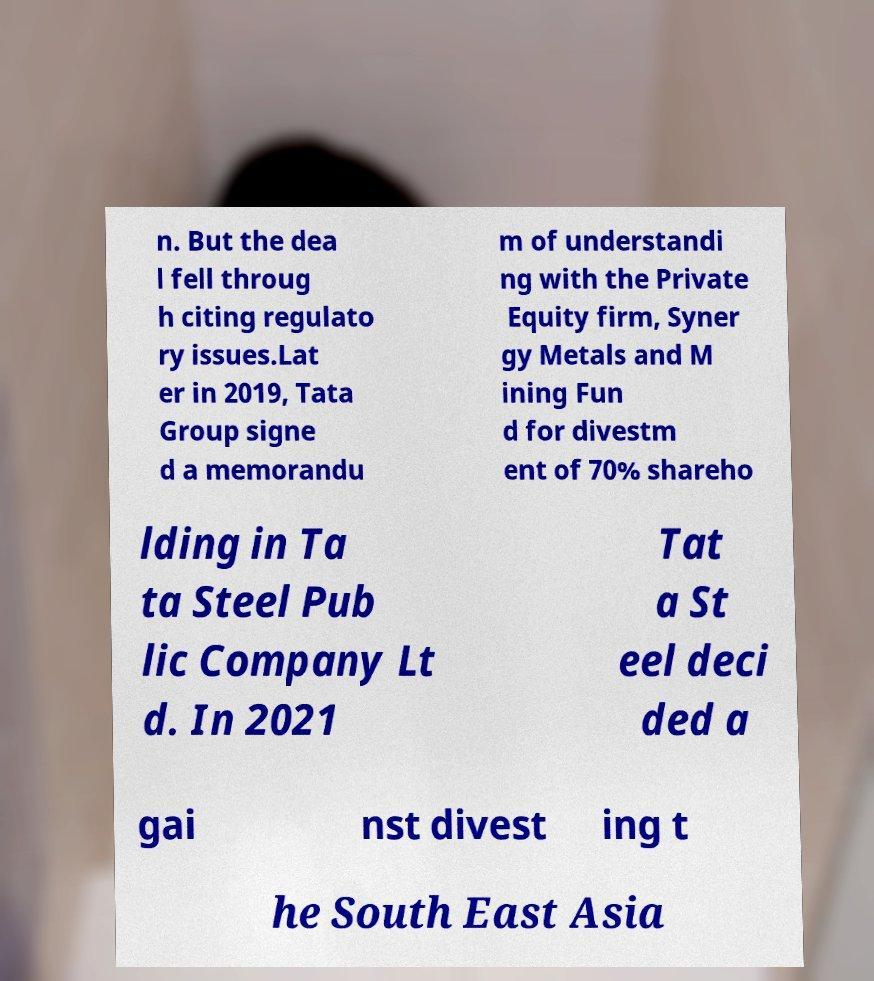Could you assist in decoding the text presented in this image and type it out clearly? n. But the dea l fell throug h citing regulato ry issues.Lat er in 2019, Tata Group signe d a memorandu m of understandi ng with the Private Equity firm, Syner gy Metals and M ining Fun d for divestm ent of 70% shareho lding in Ta ta Steel Pub lic Company Lt d. In 2021 Tat a St eel deci ded a gai nst divest ing t he South East Asia 